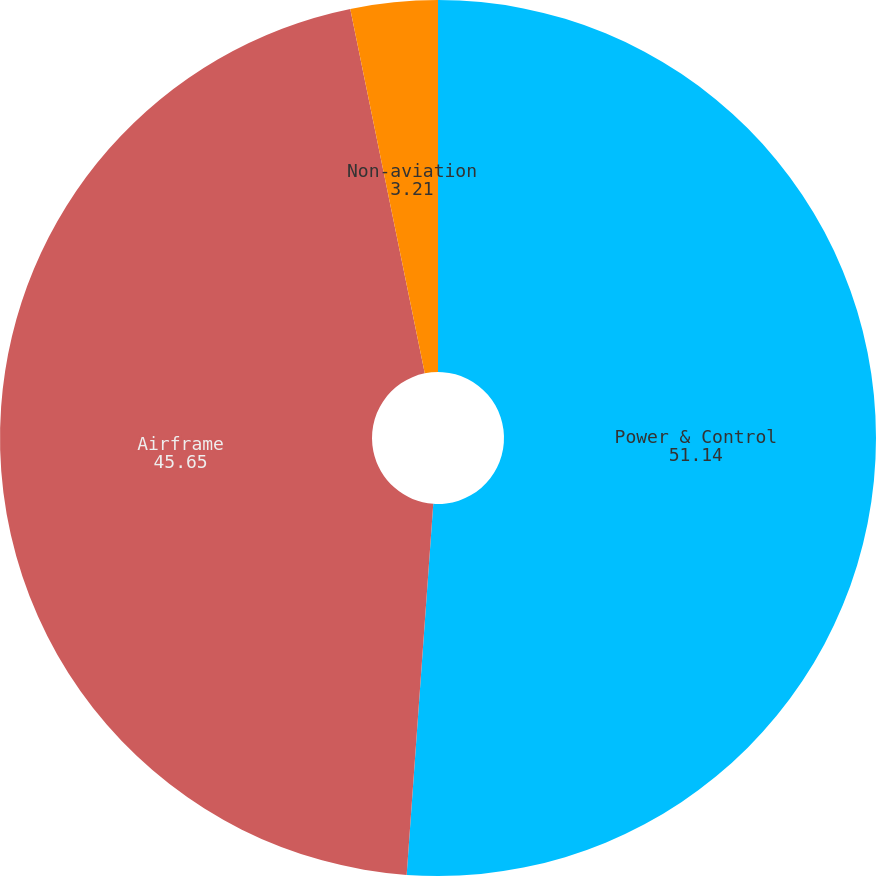Convert chart to OTSL. <chart><loc_0><loc_0><loc_500><loc_500><pie_chart><fcel>Power & Control<fcel>Airframe<fcel>Non-aviation<nl><fcel>51.14%<fcel>45.65%<fcel>3.21%<nl></chart> 